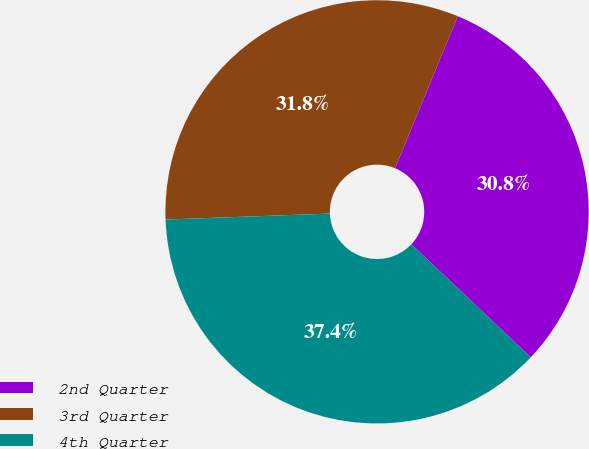Convert chart to OTSL. <chart><loc_0><loc_0><loc_500><loc_500><pie_chart><fcel>2nd Quarter<fcel>3rd Quarter<fcel>4th Quarter<nl><fcel>30.84%<fcel>31.81%<fcel>37.36%<nl></chart> 